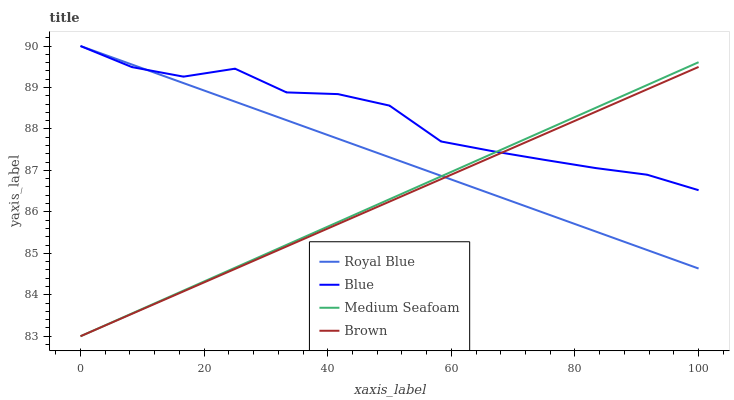Does Brown have the minimum area under the curve?
Answer yes or no. Yes. Does Blue have the maximum area under the curve?
Answer yes or no. Yes. Does Royal Blue have the minimum area under the curve?
Answer yes or no. No. Does Royal Blue have the maximum area under the curve?
Answer yes or no. No. Is Royal Blue the smoothest?
Answer yes or no. Yes. Is Blue the roughest?
Answer yes or no. Yes. Is Medium Seafoam the smoothest?
Answer yes or no. No. Is Medium Seafoam the roughest?
Answer yes or no. No. Does Medium Seafoam have the lowest value?
Answer yes or no. Yes. Does Royal Blue have the lowest value?
Answer yes or no. No. Does Royal Blue have the highest value?
Answer yes or no. Yes. Does Medium Seafoam have the highest value?
Answer yes or no. No. Does Medium Seafoam intersect Royal Blue?
Answer yes or no. Yes. Is Medium Seafoam less than Royal Blue?
Answer yes or no. No. Is Medium Seafoam greater than Royal Blue?
Answer yes or no. No. 